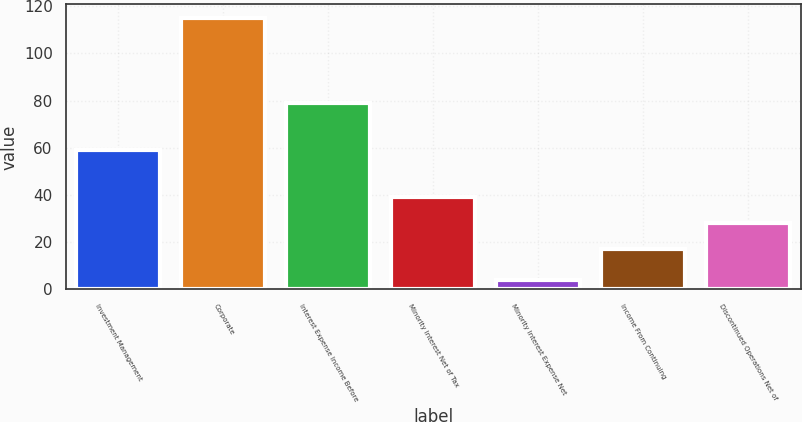<chart> <loc_0><loc_0><loc_500><loc_500><bar_chart><fcel>Investment Management<fcel>Corporate<fcel>Interest Expense Income Before<fcel>Minority Interest Net of Tax<fcel>Minority Interest Expense Net<fcel>Income From Continuing<fcel>Discontinued Operations Net of<nl><fcel>59<fcel>115<fcel>79<fcel>39.2<fcel>4<fcel>17<fcel>28.1<nl></chart> 